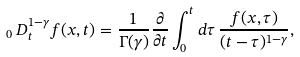<formula> <loc_0><loc_0><loc_500><loc_500>_ { 0 } \, D _ { t } ^ { 1 - \gamma } f ( x , t ) = \frac { 1 } { \Gamma ( \gamma ) } \frac { \partial } { \partial t } \int _ { 0 } ^ { t } d \tau \, \frac { f ( x , \tau ) } { ( t - \tau ) ^ { 1 - \gamma } } ,</formula> 